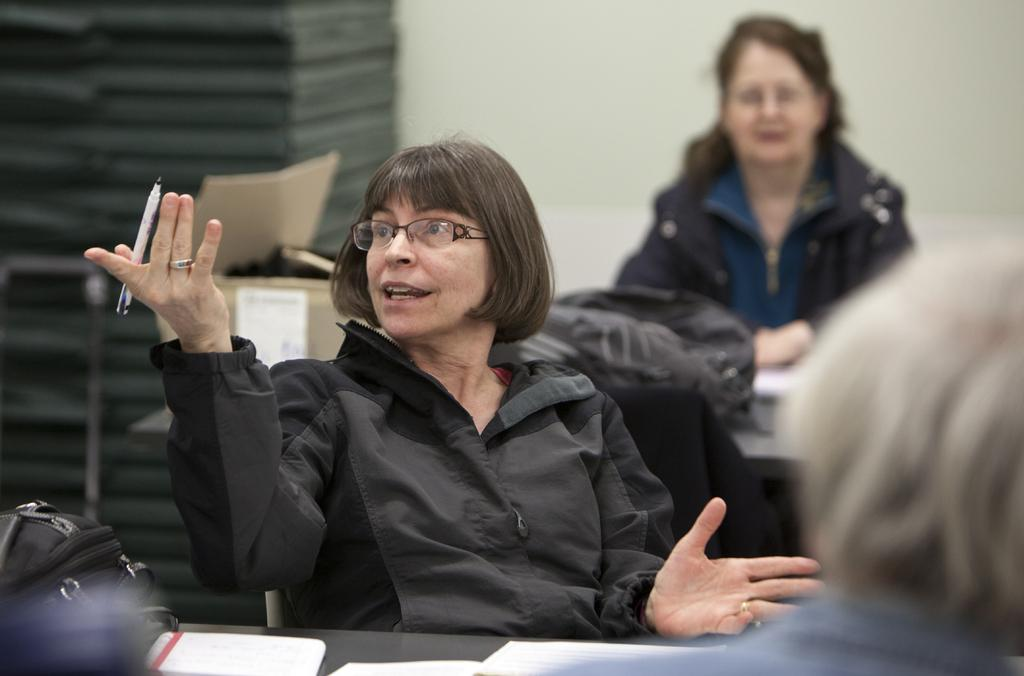What is the woman in the image doing with her hand? The woman in the image is showing her hand. What is the woman wearing in the image? The woman is wearing a black coat. What is the position of the other woman in the image? The other woman is sitting in the image. What is the sitting woman wearing in the image? The sitting woman is wearing a coat. What type of experience does the woman in the image have with painting? There is no information about the woman's experience with painting in the image. Can you describe the picture hanging on the wall behind the women? There is no mention of a picture hanging on the wall behind the women in the provided facts. 